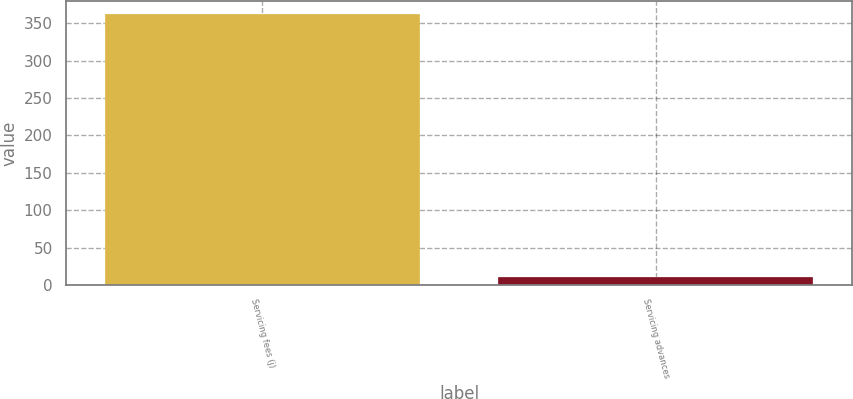Convert chart. <chart><loc_0><loc_0><loc_500><loc_500><bar_chart><fcel>Servicing fees (j)<fcel>Servicing advances<nl><fcel>362<fcel>11<nl></chart> 